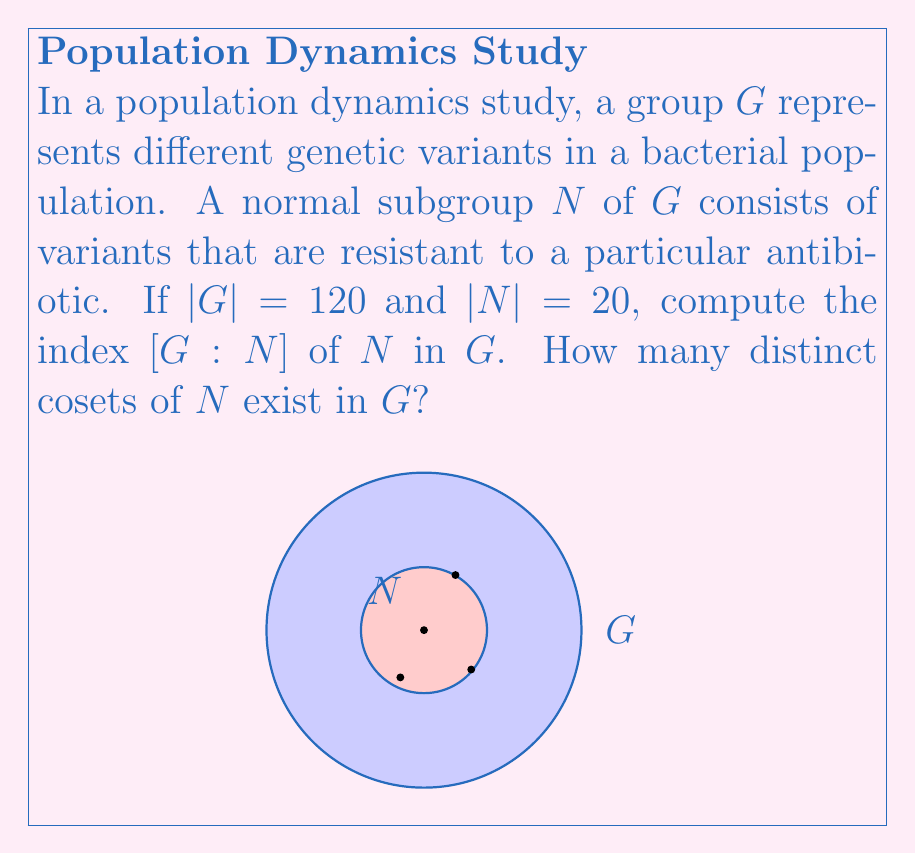Help me with this question. To solve this problem, we'll follow these steps:

1) Recall the definition of the index of a subgroup:
   The index of a subgroup $H$ in a group $G$, denoted $[G:H]$, is the number of distinct left (or right) cosets of $H$ in $G$.

2) For finite groups, there's a theorem that relates the order of the group, the order of the subgroup, and the index:

   $$[G:H] = \frac{|G|}{|H|}$$

   where $|G|$ is the order of $G$ and $|H|$ is the order of $H$.

3) In our case, we're looking for $[G:N]$ where:
   $|G| = 120$ (the order of the full group)
   $|N| = 20$ (the order of the normal subgroup)

4) Applying the formula:

   $$[G:N] = \frac{|G|}{|N|} = \frac{120}{20} = 6$$

5) Therefore, the index $[G:N]$ is 6.

6) The index also represents the number of distinct cosets of $N$ in $G$. So there are 6 distinct cosets of $N$ in $G$.

This result tells us that the bacterial population can be divided into 6 distinct groups based on their relationship to the antibiotic-resistant variants, which could be valuable information for the biology researcher studying population dynamics.
Answer: $[G:N] = 6$; 6 distinct cosets 